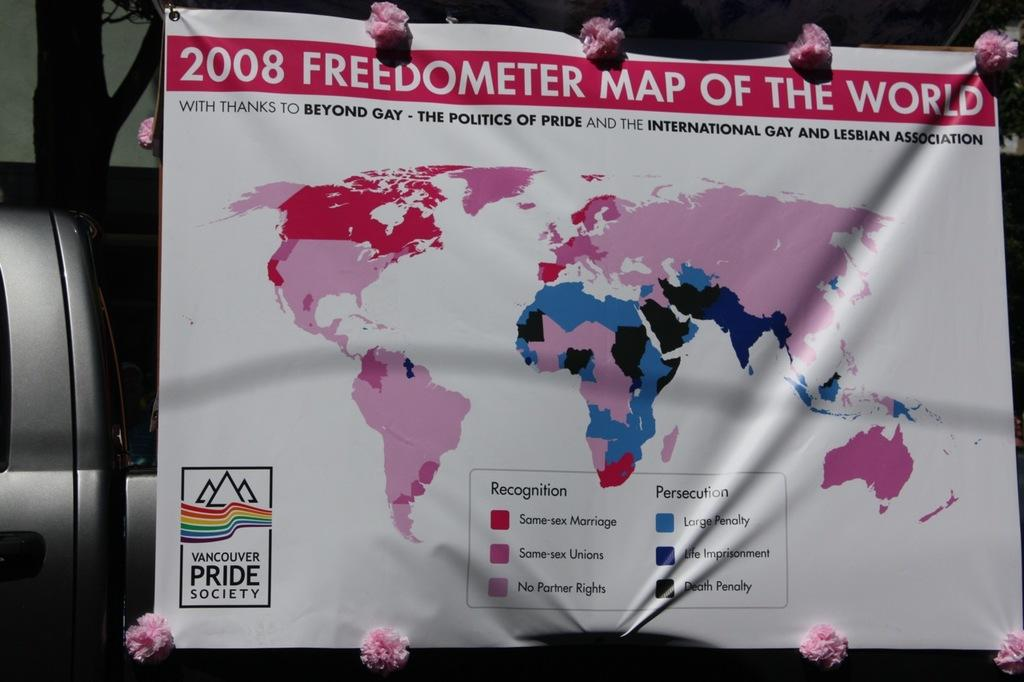<image>
Share a concise interpretation of the image provided. Map of the world hanging and a logo saying "Pride Society" on the bottom. 